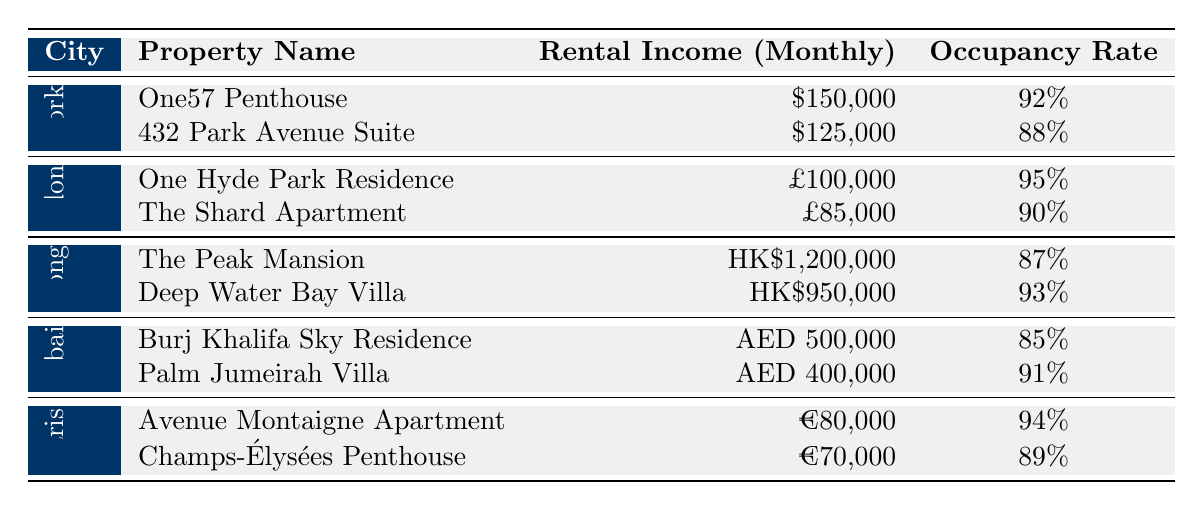What is the highest rental income among the properties listed? The highest rental income from the properties is found by comparing the values. The One57 Penthouse in New York City has a rental income of $150,000, which is higher than all other properties listed.
Answer: $150,000 What city has the property with the highest occupancy rate? The occupancy rates are compared and London has the One Hyde Park Residence with a rate of 95%, which is the highest of all properties listed.
Answer: London What is the average rental income for the properties in Dubai? The rental incomes in Dubai are AED 500,000 and AED 400,000. The average is calculated as (500,000 + 400,000) / 2 = 450,000.
Answer: AED 450,000 Which property has the lowest occupancy rate? Reviewing the occupancy rates, Burj Khalifa Sky Residence in Dubai has the lowest rate at 85%, which is lower than all other properties.
Answer: Burj Khalifa Sky Residence Is the rental income of the One Hyde Park Residence higher than that of the Champs-Élysées Penthouse? The One Hyde Park Residence has a rental income of £100,000 and the Champs-Élysées Penthouse has €70,000. Converting currencies is not necessary for direct comparison here, as we can infer the property from London tends to have a higher rental value.
Answer: Yes What is the total rental income for properties in New York City? The rental income for One57 Penthouse is $150,000 and for 432 Park Avenue Suite is $125,000. So, total rental income is $150,000 + $125,000 = $275,000.
Answer: $275,000 Which city has the average occupancy rate above 90%? Evaluating the occupancy rates, New York City has an average of (92% + 88%)/2 = 90%, London has (95% + 90%)/2 = 92.5%, Hong Kong (87% + 93%)/2 = 90%, and Dubai (85% + 91%)/2 = 88%. Only London has an average occupancy rate above 90%.
Answer: London What is the occupancy rate difference between The Peak Mansion and the Burj Khalifa Sky Residence? The Peak Mansion has an occupancy rate of 87% and Burj Khalifa Sky Residence has 85%. The difference is calculated as 87% - 85% = 2%.
Answer: 2% In which city do both properties have an occupancy rate above 90%? Reviewing the properties, the Deep Water Bay Villa in Hong Kong has a rate of 93% and the Palm Jumeirah Villa in Dubai has 91%. Both properties exceed 90%, but Hong Kong has two properties with rates above 90%.
Answer: Hong Kong Which property from the given table generates more rental income, the Avenue Montaigne Apartment or the 432 Park Avenue Suite? The Avenue Montaigne Apartment generates €80,000, while the 432 Park Avenue Suite generates $125,000. Assuming conversion rates, $125,000 is significantly higher than €80,000.
Answer: 432 Park Avenue Suite 